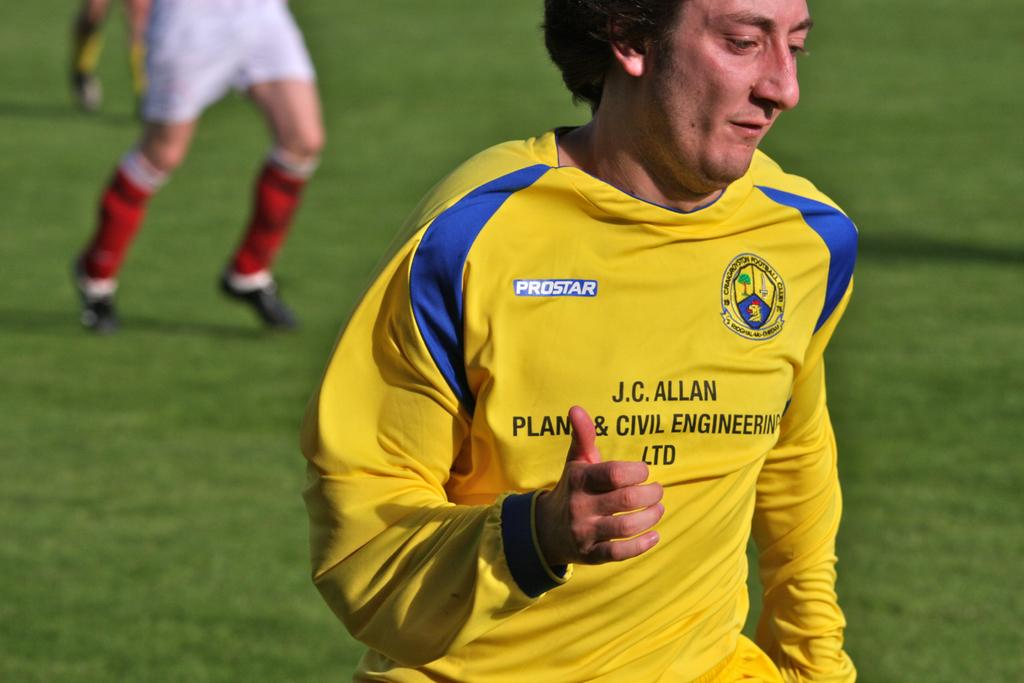<image>
Write a terse but informative summary of the picture. A man wears a yellow and blue shirt which has the words Civil Engineering on it. 